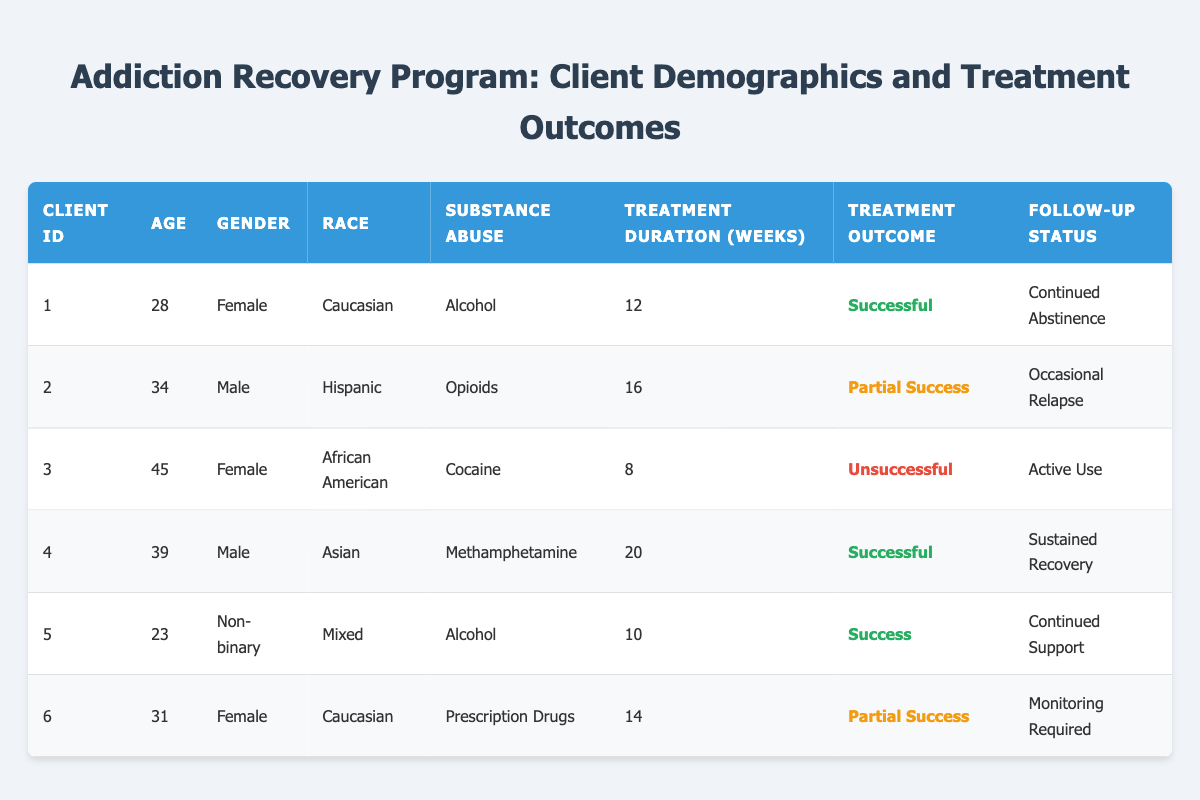What is the treatment outcome for client ID 1? From the table, I locate the row for client ID 1 and see that the treatment outcome is labeled as "Successful".
Answer: Successful How many clients are in the age group of 30 to 40? I review the age column and count the clients aged 30–39. Client IDs 2, 4, and 6 fall within this age range, giving a total of 3 clients.
Answer: 3 What is the follow-up status for the client who had a successful treatment outcome? I look for the clients marked with "Successful" in the treatment outcome column. Clients ID 1 and 4 have this status. Their follow-up statuses are "Continued Abstinence" and "Sustained Recovery", respectively.
Answer: Continued Abstinence and Sustained Recovery Is there any client who reported continuing support after treatment? I check the follow-up status for each client. Client ID 5 has a follow-up status of "Continued Support", confirming that yes, there is such a client.
Answer: Yes What is the average treatment duration for clients with a partial success outcome? I find the treatment durations for clients with "Partial Success", which are clients ID 2 and 6. Their durations are 16 and 14 weeks, respectively. The sum is 30 weeks, and there are 2 clients, so the average is 30/2 = 15 weeks.
Answer: 15 weeks How many female clients had an unsuccessful treatment outcome? I scan the gender column for "Female" clients and check their treatment outcomes. Client ID 3 is the only one marked as "Unsuccessful". Thus, there is 1 female client with that outcome.
Answer: 1 Which substance abuse category has the highest successful treatment outcomes? I analyze the treatment outcomes and substance abuse categories. Alcohol (clients ID 1 and 5) and Methamphetamine (client ID 4) both have successful outcomes. However, the substance abuse categories Alcohol has 2 and Methamphetamine has 1 successful outcome, hence Alcohol is the category with the highest successful outcomes.
Answer: Alcohol What percentage of clients had a follow-up status requiring monitoring? I check the follow-up statuses and see that client ID 6 is marked as "Monitoring Required". Since there are 6 clients total, the percentage is (1/6)*100 = 16.67%.
Answer: 16.67% 